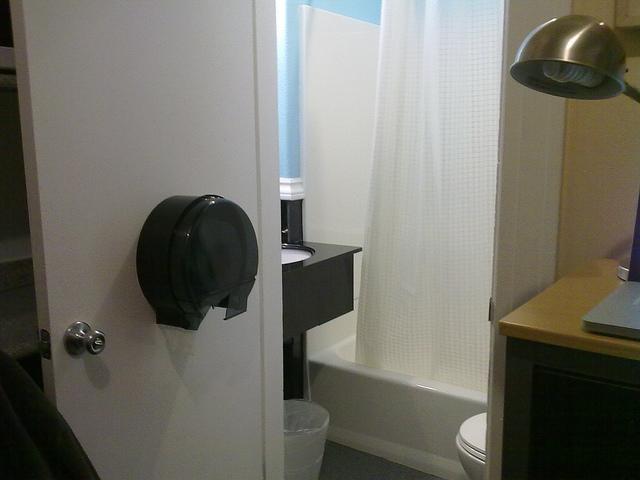How many ties are shown?
Give a very brief answer. 0. 